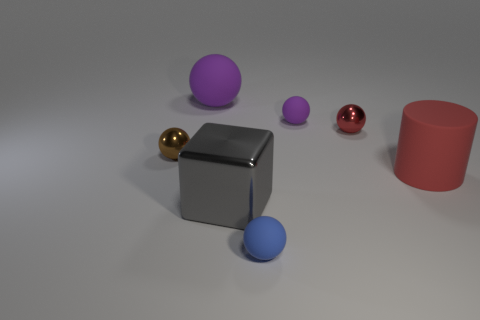Subtract all small purple matte balls. How many balls are left? 4 Subtract all blue spheres. How many spheres are left? 4 Subtract all green spheres. Subtract all cyan cubes. How many spheres are left? 5 Add 2 small rubber spheres. How many objects exist? 9 Subtract all cylinders. How many objects are left? 6 Add 2 tiny blue objects. How many tiny blue objects are left? 3 Add 5 tiny brown shiny spheres. How many tiny brown shiny spheres exist? 6 Subtract 0 blue cylinders. How many objects are left? 7 Subtract all large green metal objects. Subtract all small rubber spheres. How many objects are left? 5 